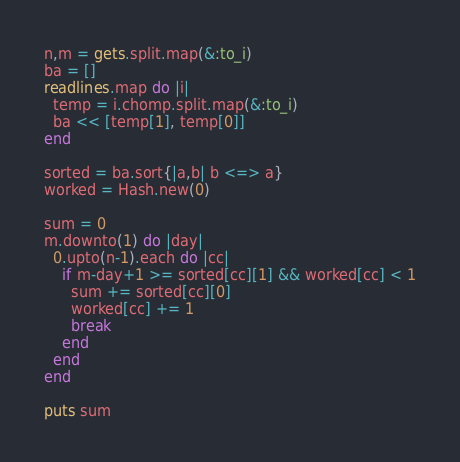<code> <loc_0><loc_0><loc_500><loc_500><_Ruby_>n,m = gets.split.map(&:to_i)
ba = []
readlines.map do |i|
  temp = i.chomp.split.map(&:to_i)
  ba << [temp[1], temp[0]]
end

sorted = ba.sort{|a,b| b <=> a}
worked = Hash.new(0)

sum = 0
m.downto(1) do |day|
  0.upto(n-1).each do |cc|
    if m-day+1 >= sorted[cc][1] && worked[cc] < 1
      sum += sorted[cc][0]
      worked[cc] += 1
      break
    end
  end
end

puts sum
</code> 